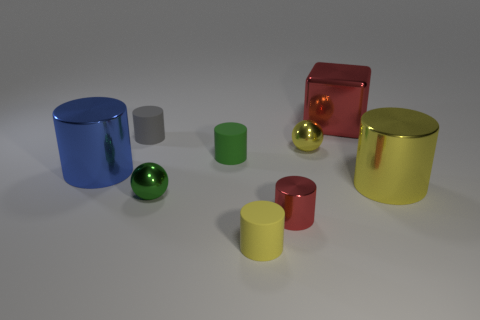Subtract all blue cylinders. How many cylinders are left? 5 Subtract all purple spheres. How many yellow cylinders are left? 2 Add 1 matte things. How many objects exist? 10 Subtract 4 cylinders. How many cylinders are left? 2 Subtract all blue cylinders. How many cylinders are left? 5 Subtract all cubes. How many objects are left? 8 Subtract 0 cyan balls. How many objects are left? 9 Subtract all blue cubes. Subtract all purple cylinders. How many cubes are left? 1 Subtract all large green shiny objects. Subtract all green objects. How many objects are left? 7 Add 7 shiny spheres. How many shiny spheres are left? 9 